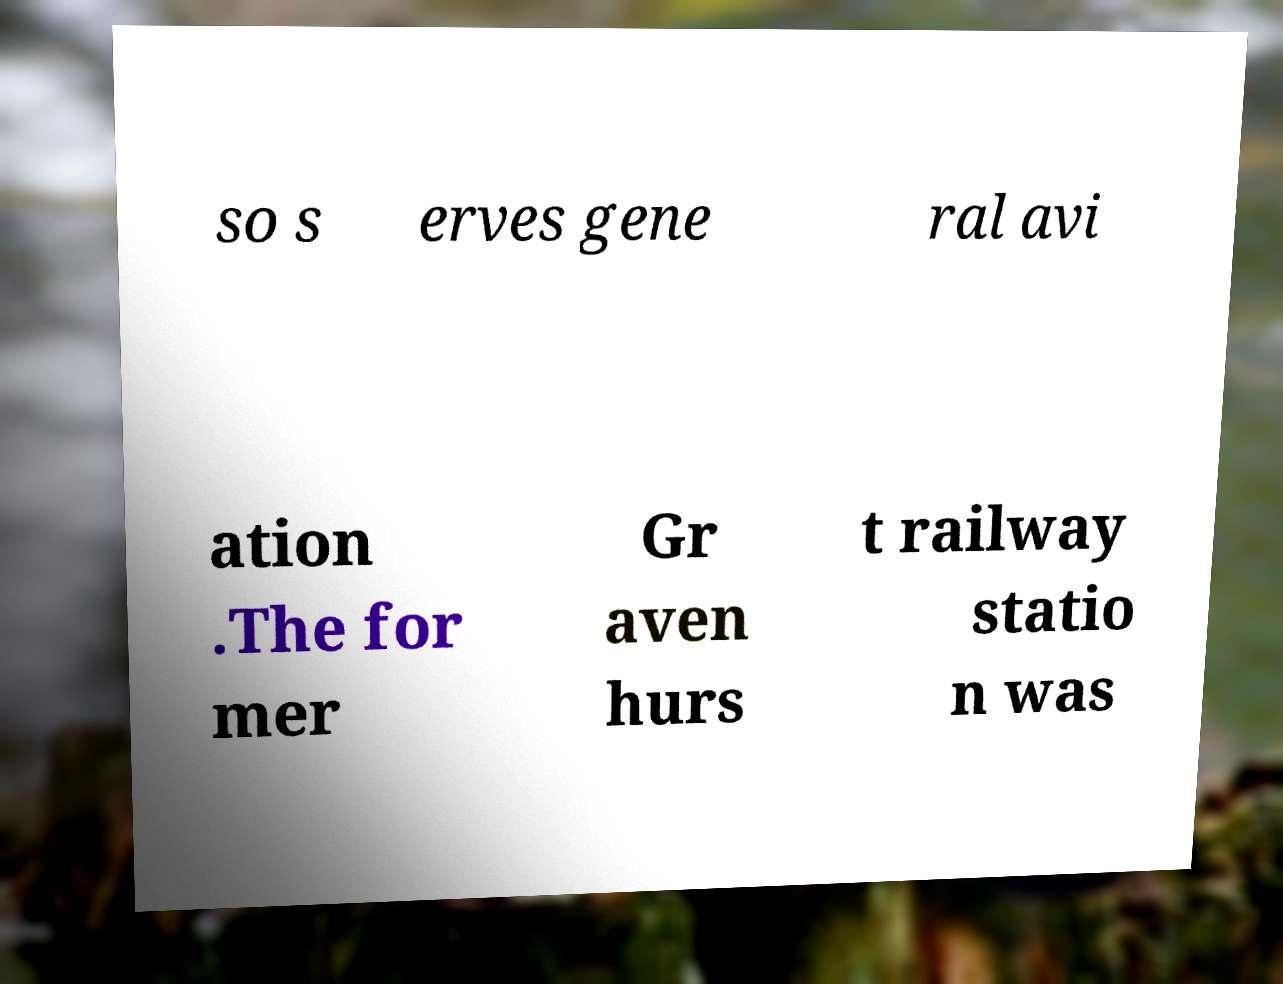Could you extract and type out the text from this image? so s erves gene ral avi ation .The for mer Gr aven hurs t railway statio n was 